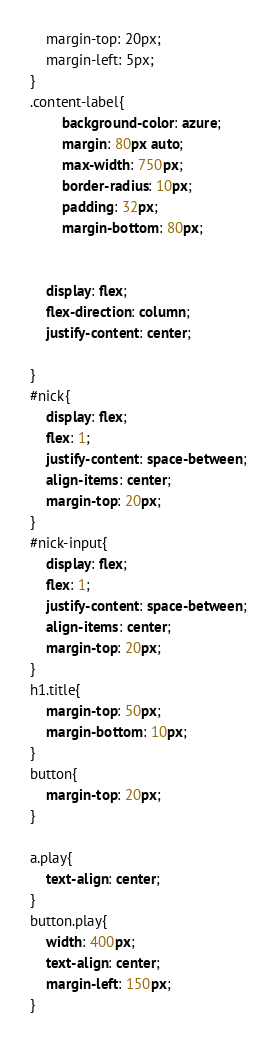<code> <loc_0><loc_0><loc_500><loc_500><_CSS_>    margin-top: 20px;
    margin-left: 5px;
}
.content-label{
        background-color: azure;
        margin: 80px auto;
        max-width: 750px;
        border-radius: 10px;
        padding: 32px;
        margin-bottom: 80px;
        
    
    display: flex;
    flex-direction: column;
    justify-content: center;

}
#nick{
    display: flex;
    flex: 1;
    justify-content: space-between;
    align-items: center;
    margin-top: 20px;
}
#nick-input{
    display: flex;
    flex: 1;
    justify-content: space-between;
    align-items: center;
    margin-top: 20px;
}
h1.title{
    margin-top: 50px;
    margin-bottom: 10px;
}
button{    
    margin-top: 20px;
}

a.play{
    text-align: center;
}
button.play{
    width: 400px;
    text-align: center;
    margin-left: 150px;
}</code> 